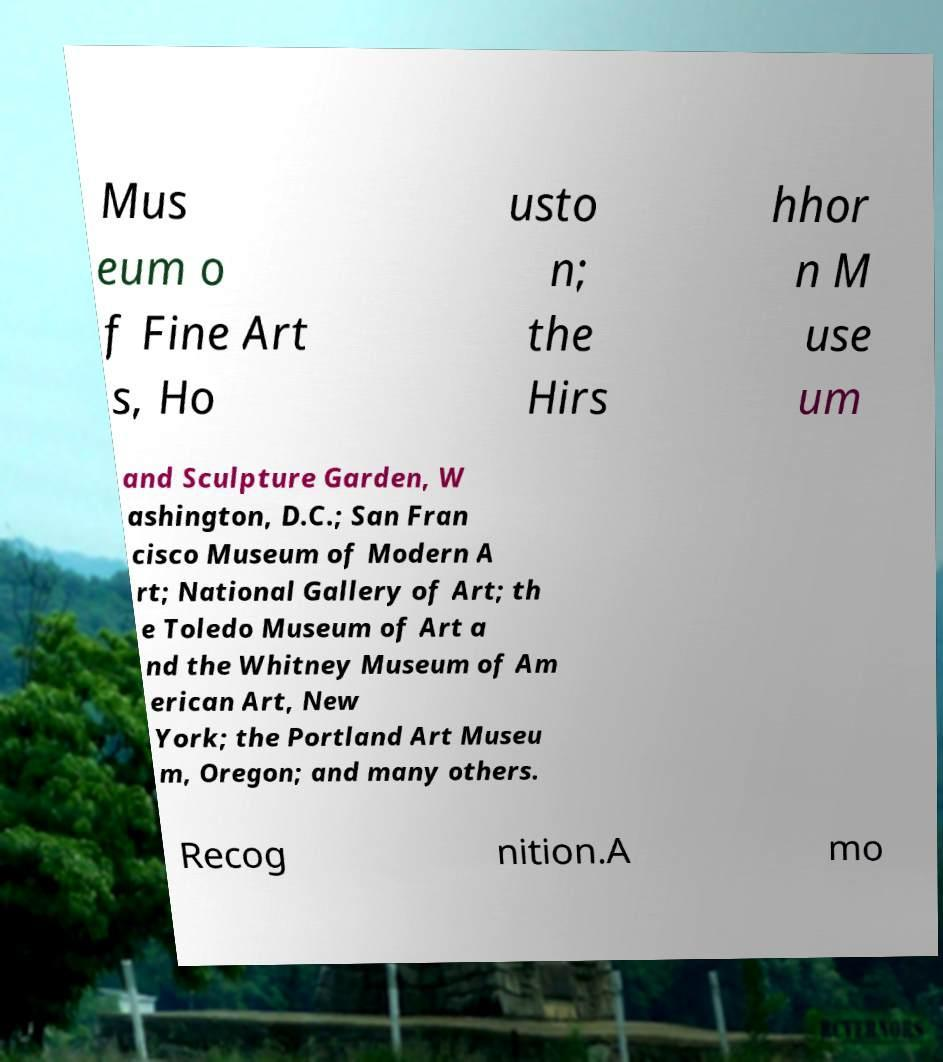Please identify and transcribe the text found in this image. Mus eum o f Fine Art s, Ho usto n; the Hirs hhor n M use um and Sculpture Garden, W ashington, D.C.; San Fran cisco Museum of Modern A rt; National Gallery of Art; th e Toledo Museum of Art a nd the Whitney Museum of Am erican Art, New York; the Portland Art Museu m, Oregon; and many others. Recog nition.A mo 